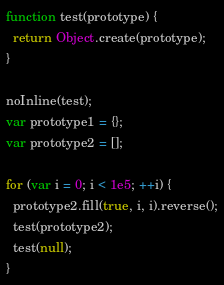Convert code to text. <code><loc_0><loc_0><loc_500><loc_500><_JavaScript_>function test(prototype) {
  return Object.create(prototype);
}

noInline(test);
var prototype1 = {};
var prototype2 = [];

for (var i = 0; i < 1e5; ++i) {
  prototype2.fill(true, i, i).reverse();
  test(prototype2);
  test(null);
}
</code> 